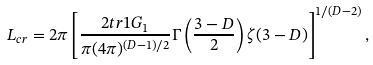Convert formula to latex. <formula><loc_0><loc_0><loc_500><loc_500>L _ { c r } = 2 \pi \left [ \frac { 2 t r 1 G _ { 1 } } { \pi ( 4 \pi ) ^ { ( D - 1 ) / 2 } } \Gamma \left ( \frac { 3 - D } { 2 } \right ) \zeta ( 3 - D ) \right ] ^ { 1 / ( D - 2 ) } ,</formula> 